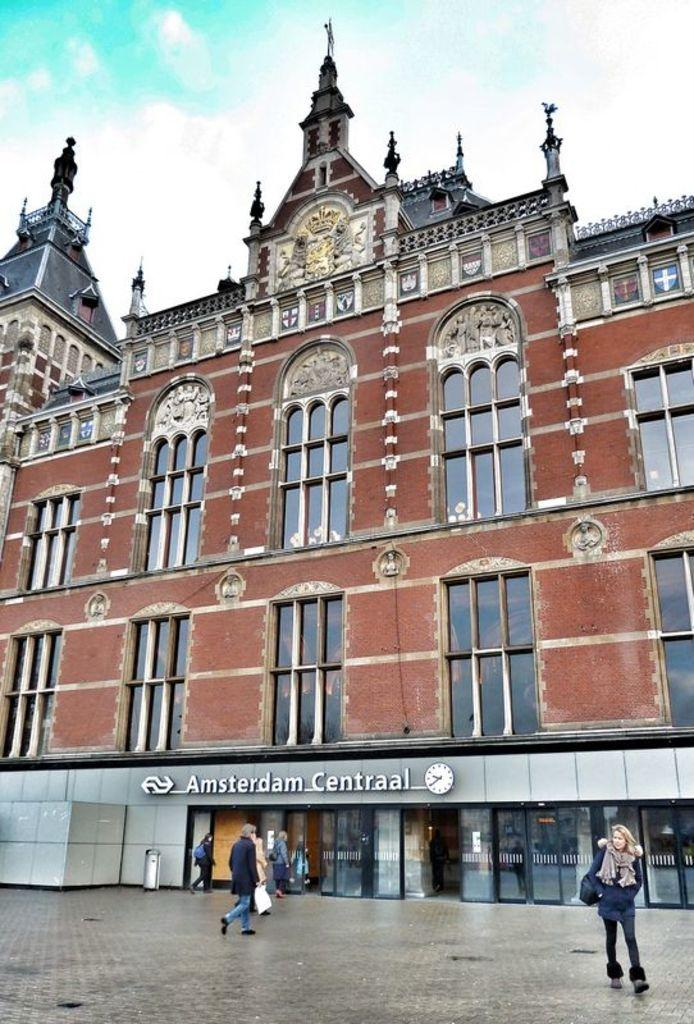What type of structure is present in the image? There is a building in the image. What feature can be seen on the building? The building has windows. What sign is visible in the image? There is a name board in the image. What objects are present for waste disposal? There are bins in the image. Who or what can be seen on the floor in the image? There are persons standing on the floor in the image. What can be seen in the distance in the image? The sky with clouds is visible in the background of the image. What is the limit of the rain in the image? There is no rain present in the image, so there is no limit to discuss. What part of the building is not visible in the image? The image only shows a portion of the building, so it's impossible to determine which part is not visible. 